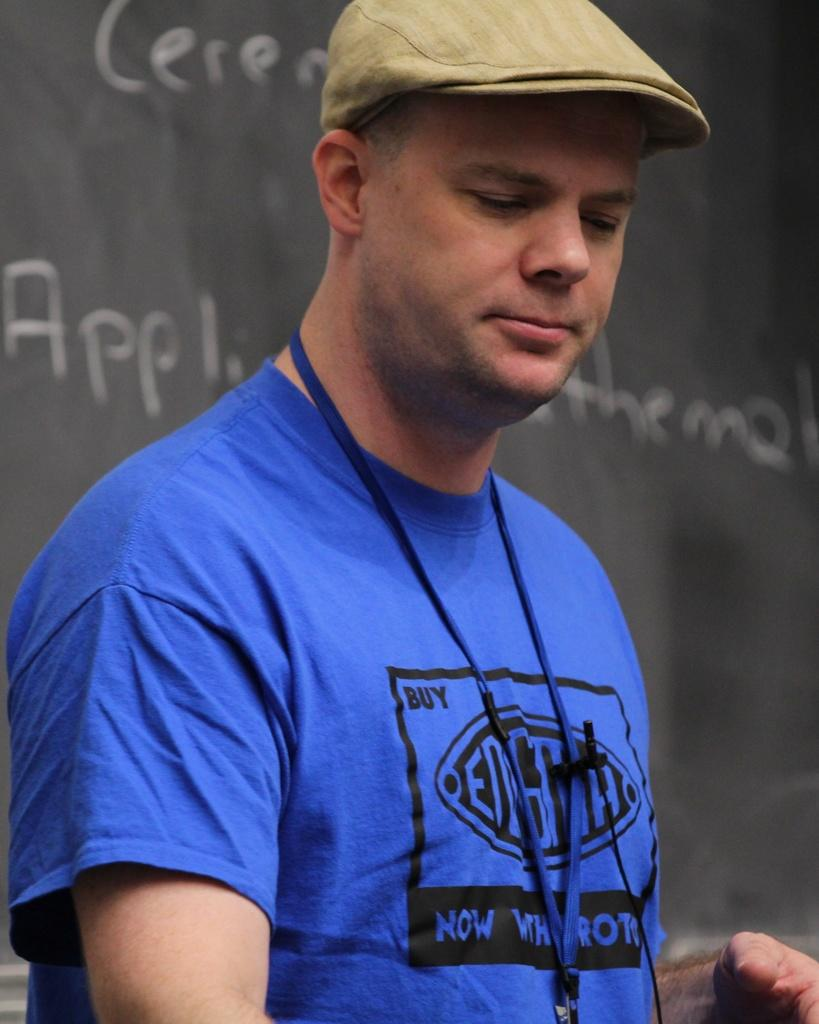<image>
Share a concise interpretation of the image provided. A man with a blue shirt that says Buy in the top left corner of a black square, is standing in front of a black board with writing on it. 